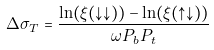<formula> <loc_0><loc_0><loc_500><loc_500>\Delta \sigma _ { T } = \frac { \ln ( \xi ( \downarrow \downarrow ) ) - \ln ( \xi ( \uparrow \downarrow ) ) } { \omega P _ { b } P _ { t } }</formula> 